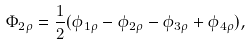<formula> <loc_0><loc_0><loc_500><loc_500>\Phi _ { 2 \rho } = \frac { 1 } { 2 } ( \phi _ { 1 \rho } - \phi _ { 2 \rho } - \phi _ { 3 \rho } + \phi _ { 4 \rho } ) ,</formula> 